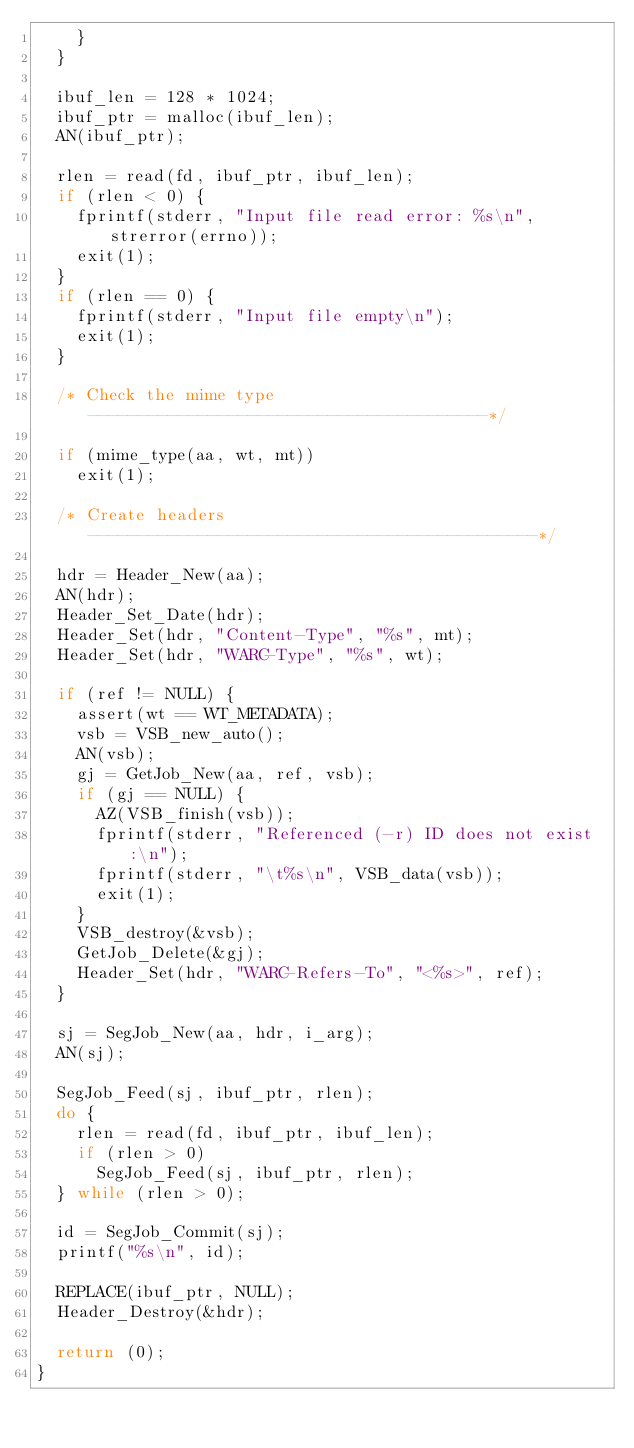Convert code to text. <code><loc_0><loc_0><loc_500><loc_500><_C_>		}
	}

	ibuf_len = 128 * 1024;
	ibuf_ptr = malloc(ibuf_len);
	AN(ibuf_ptr);

	rlen = read(fd, ibuf_ptr, ibuf_len);
	if (rlen < 0) {
		fprintf(stderr, "Input file read error: %s\n", strerror(errno));
		exit(1);
	}
	if (rlen == 0) {
		fprintf(stderr, "Input file empty\n");
		exit(1);
	}

	/* Check the mime type ----------------------------------------*/

	if (mime_type(aa, wt, mt))
		exit(1);

	/* Create headers ---------------------------------------------*/

	hdr = Header_New(aa);
	AN(hdr);
	Header_Set_Date(hdr);
	Header_Set(hdr, "Content-Type", "%s", mt);
	Header_Set(hdr, "WARC-Type", "%s", wt);

	if (ref != NULL) {
		assert(wt == WT_METADATA);
		vsb = VSB_new_auto();
		AN(vsb);
		gj = GetJob_New(aa, ref, vsb);
		if (gj == NULL) {
			AZ(VSB_finish(vsb));
			fprintf(stderr, "Referenced (-r) ID does not exist:\n");
			fprintf(stderr, "\t%s\n", VSB_data(vsb));
			exit(1);
		}
		VSB_destroy(&vsb);
		GetJob_Delete(&gj);
		Header_Set(hdr, "WARC-Refers-To", "<%s>", ref);
	}

	sj = SegJob_New(aa, hdr, i_arg);
	AN(sj);

	SegJob_Feed(sj, ibuf_ptr, rlen);
	do {
		rlen = read(fd, ibuf_ptr, ibuf_len);
		if (rlen > 0)
			SegJob_Feed(sj, ibuf_ptr, rlen);
	} while (rlen > 0);

	id = SegJob_Commit(sj);
	printf("%s\n", id);

	REPLACE(ibuf_ptr, NULL);
	Header_Destroy(&hdr);

	return (0);
}
</code> 